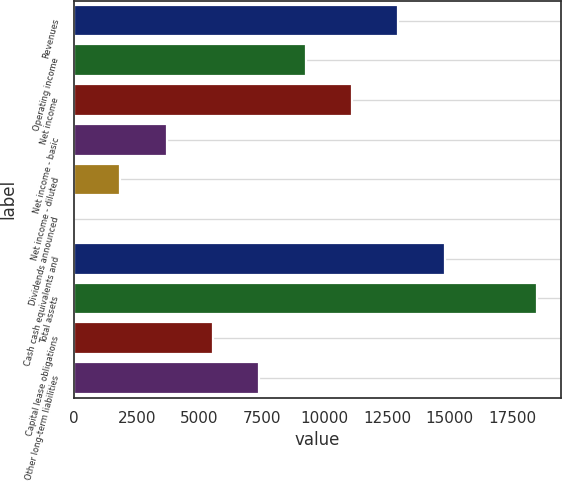Convert chart to OTSL. <chart><loc_0><loc_0><loc_500><loc_500><bar_chart><fcel>Revenues<fcel>Operating income<fcel>Net income<fcel>Net income - basic<fcel>Net income - diluted<fcel>Dividends announced<fcel>Cash cash equivalents and<fcel>Total assets<fcel>Capital lease obligations<fcel>Other long-term liabilities<nl><fcel>12946.7<fcel>9247.77<fcel>11097.2<fcel>3699.42<fcel>1849.97<fcel>0.52<fcel>14796.1<fcel>18495<fcel>5548.87<fcel>7398.32<nl></chart> 